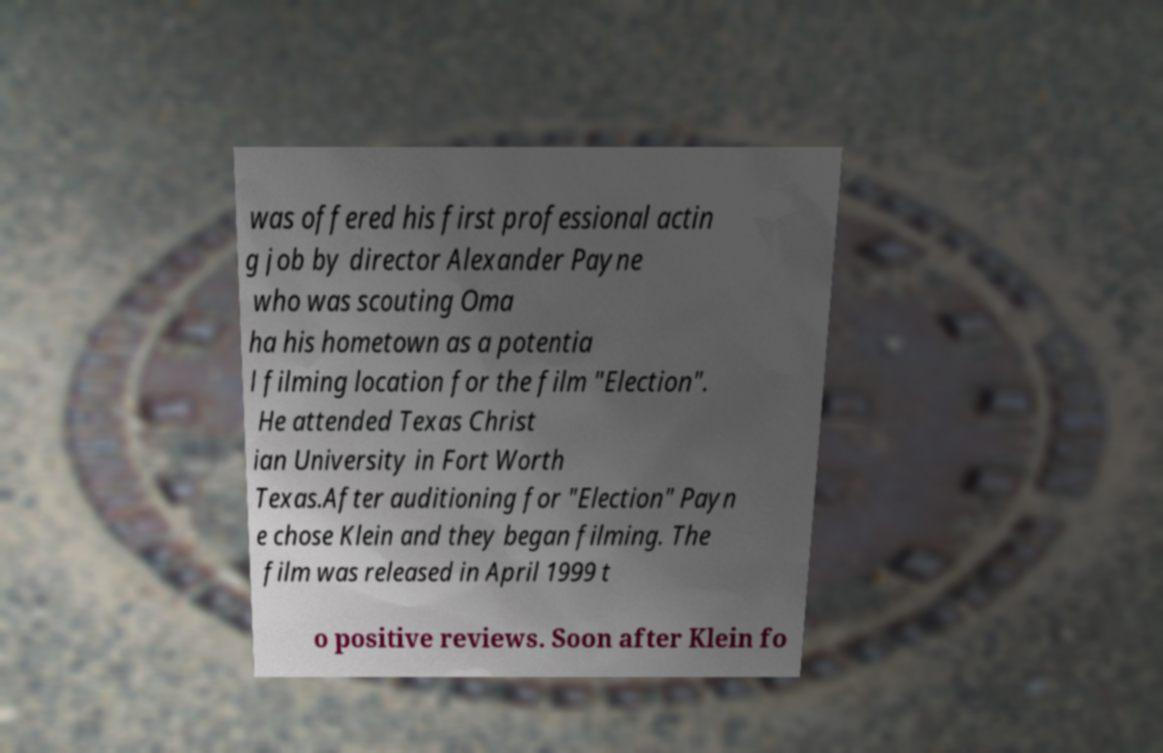What messages or text are displayed in this image? I need them in a readable, typed format. was offered his first professional actin g job by director Alexander Payne who was scouting Oma ha his hometown as a potentia l filming location for the film "Election". He attended Texas Christ ian University in Fort Worth Texas.After auditioning for "Election" Payn e chose Klein and they began filming. The film was released in April 1999 t o positive reviews. Soon after Klein fo 